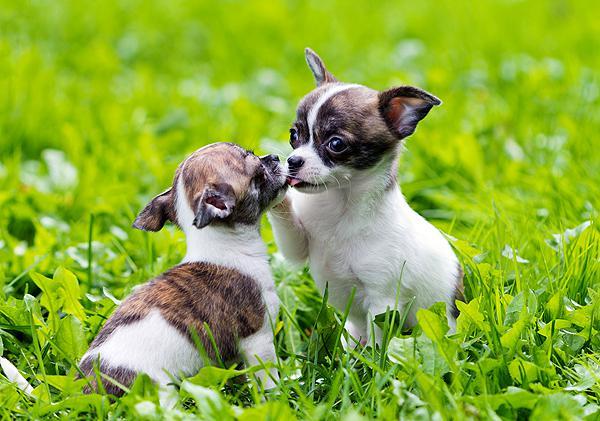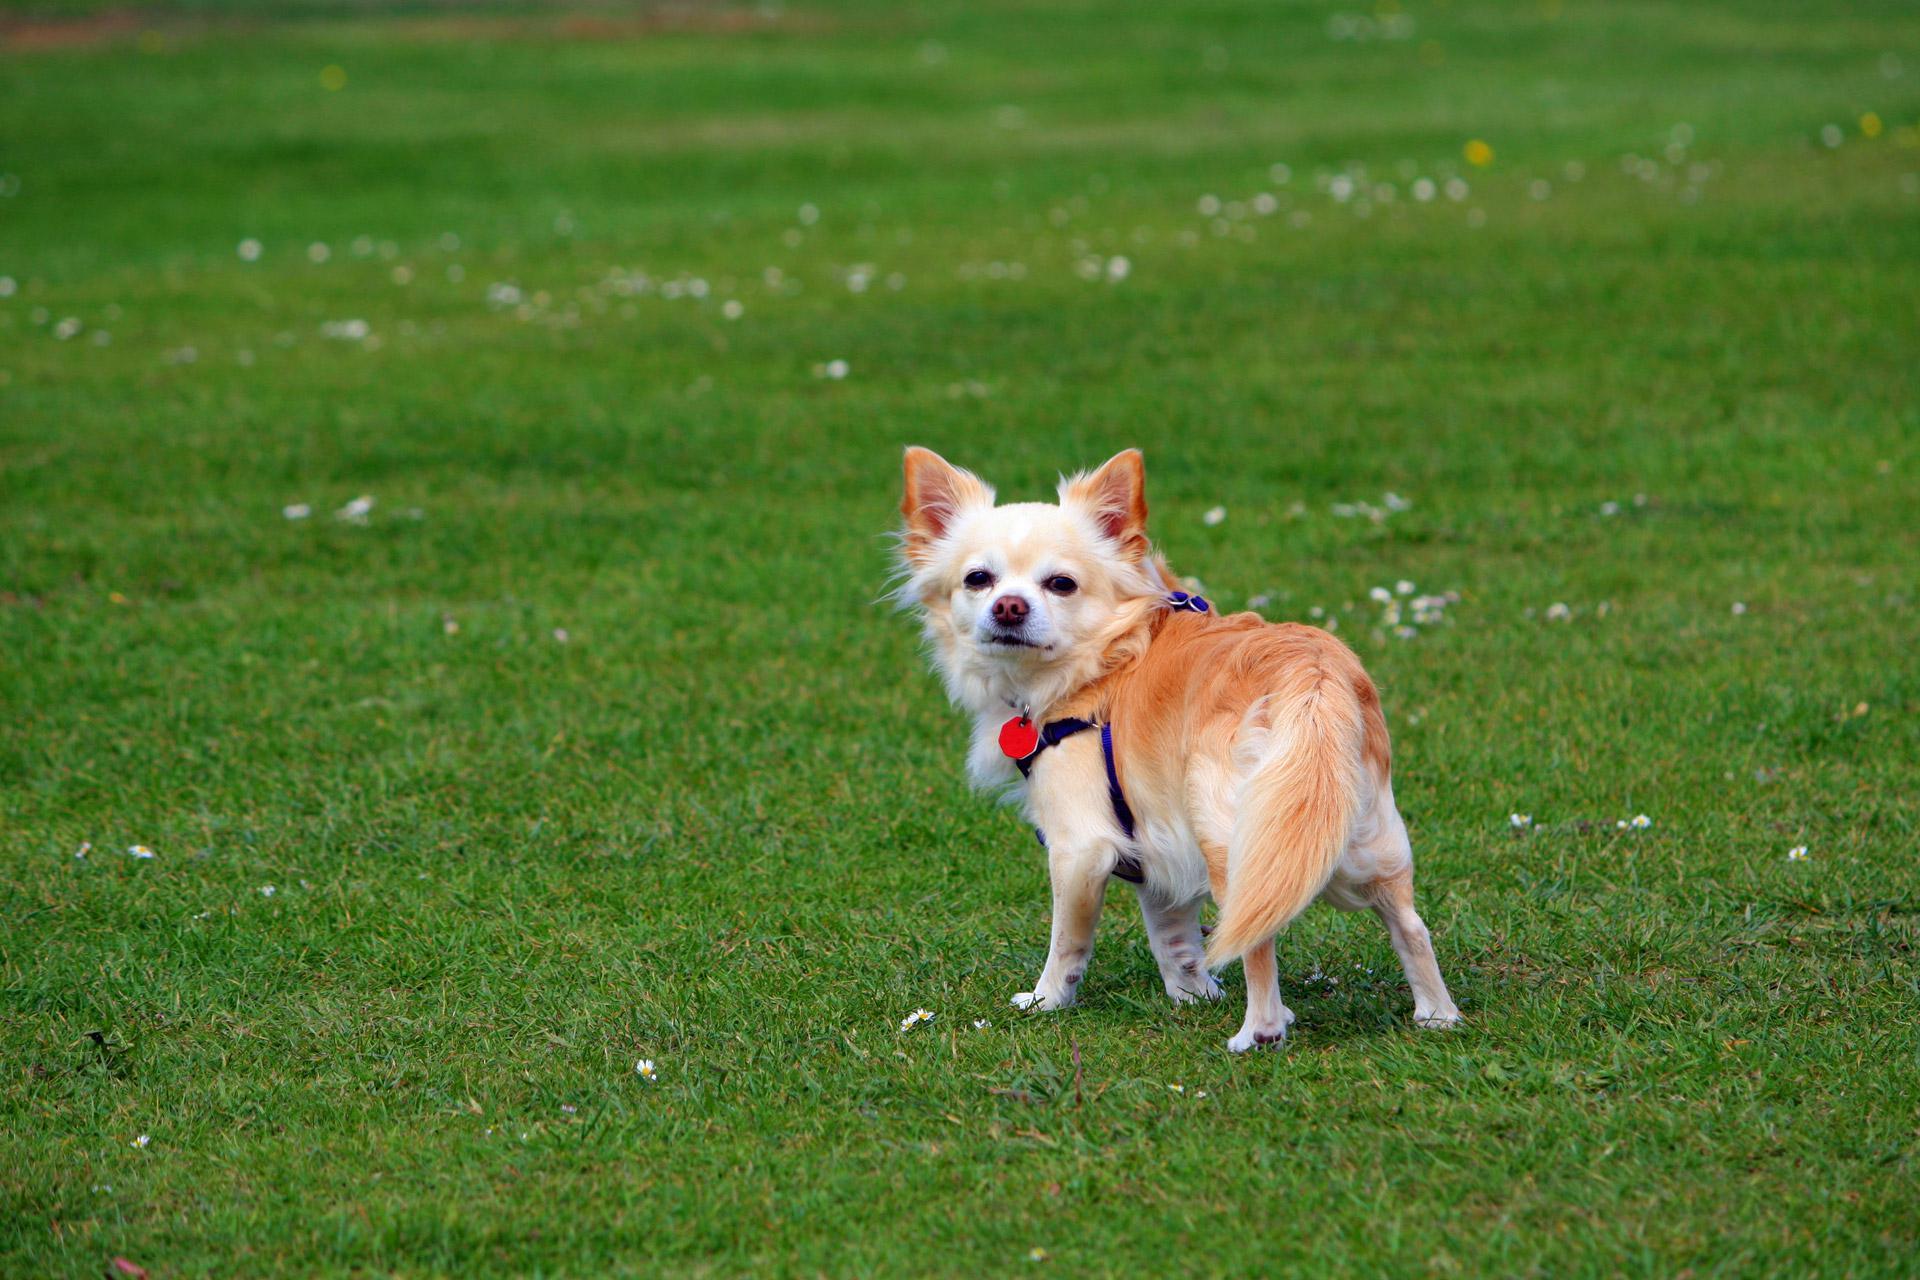The first image is the image on the left, the second image is the image on the right. Examine the images to the left and right. Is the description "Left image features two small dogs with no collars or leashes." accurate? Answer yes or no. Yes. The first image is the image on the left, the second image is the image on the right. For the images shown, is this caption "One dog's tail is fluffy." true? Answer yes or no. Yes. 